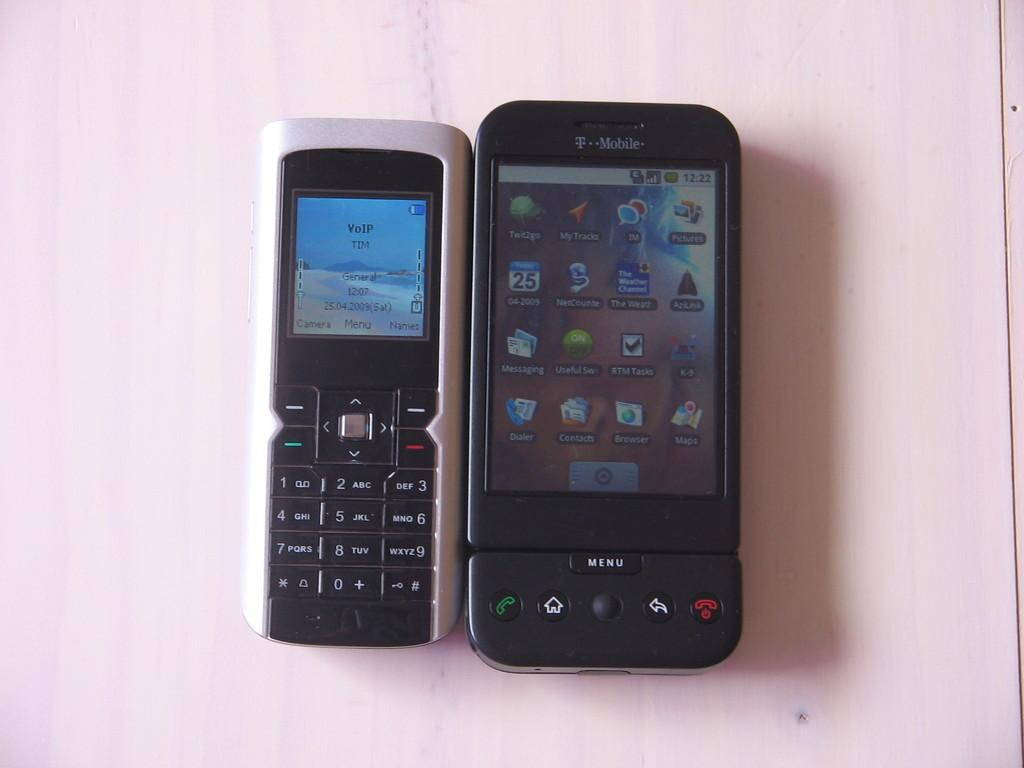<image>
Give a short and clear explanation of the subsequent image. Two T-Mobile phones next to each other on a pink table. 